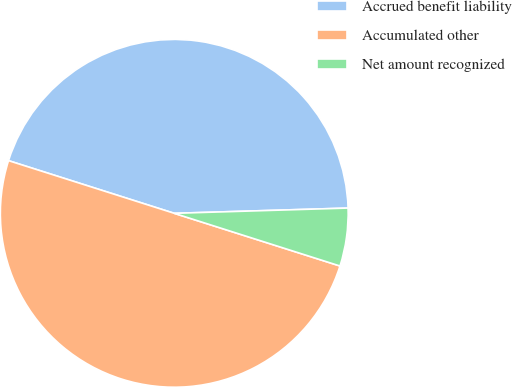Convert chart to OTSL. <chart><loc_0><loc_0><loc_500><loc_500><pie_chart><fcel>Accrued benefit liability<fcel>Accumulated other<fcel>Net amount recognized<nl><fcel>44.62%<fcel>50.0%<fcel>5.38%<nl></chart> 